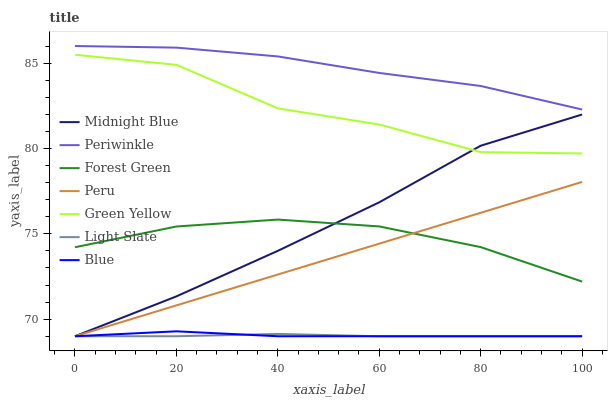Does Midnight Blue have the minimum area under the curve?
Answer yes or no. No. Does Midnight Blue have the maximum area under the curve?
Answer yes or no. No. Is Midnight Blue the smoothest?
Answer yes or no. No. Is Midnight Blue the roughest?
Answer yes or no. No. Does Forest Green have the lowest value?
Answer yes or no. No. Does Midnight Blue have the highest value?
Answer yes or no. No. Is Light Slate less than Forest Green?
Answer yes or no. Yes. Is Green Yellow greater than Blue?
Answer yes or no. Yes. Does Light Slate intersect Forest Green?
Answer yes or no. No. 